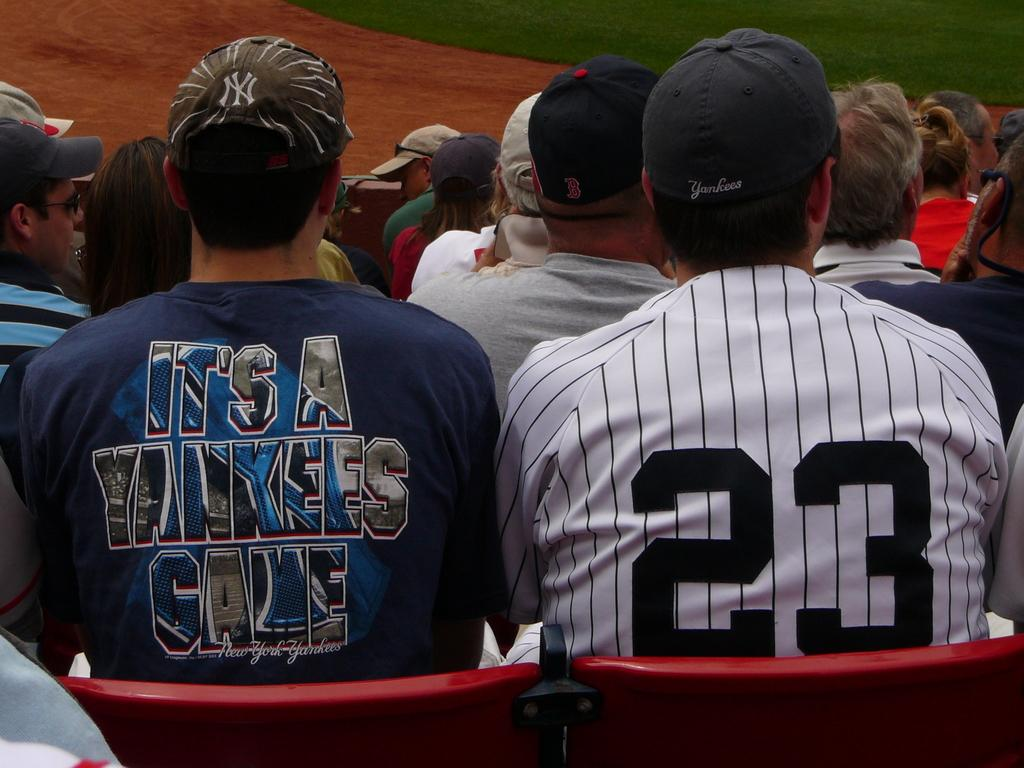<image>
Summarize the visual content of the image. a couple guys, one with a Yankees shirt on 